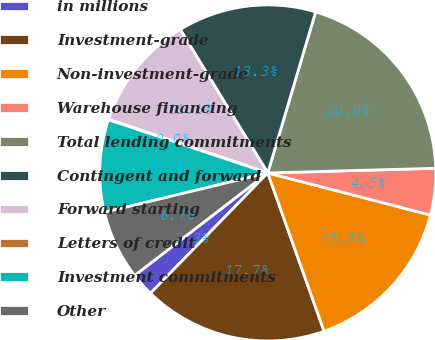Convert chart to OTSL. <chart><loc_0><loc_0><loc_500><loc_500><pie_chart><fcel>in millions<fcel>Investment-grade<fcel>Non-investment-grade<fcel>Warehouse financing<fcel>Total lending commitments<fcel>Contingent and forward<fcel>Forward starting<fcel>Letters of credit<fcel>Investment commitments<fcel>Other<nl><fcel>2.26%<fcel>17.74%<fcel>15.53%<fcel>4.47%<fcel>19.96%<fcel>13.32%<fcel>11.11%<fcel>0.04%<fcel>8.89%<fcel>6.68%<nl></chart> 